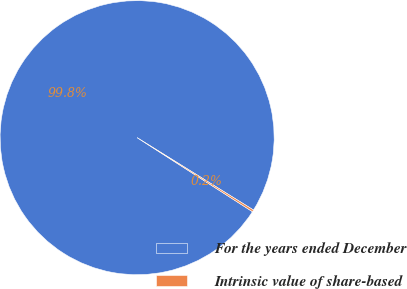Convert chart to OTSL. <chart><loc_0><loc_0><loc_500><loc_500><pie_chart><fcel>For the years ended December<fcel>Intrinsic value of share-based<nl><fcel>99.77%<fcel>0.23%<nl></chart> 